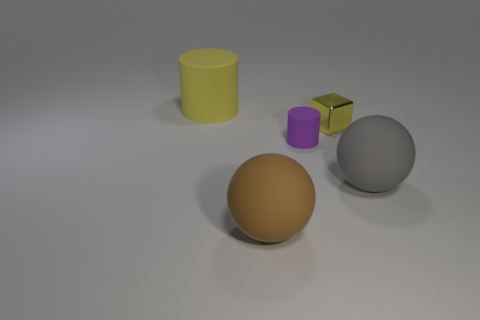Subtract all blocks. How many objects are left? 4 Add 4 large brown shiny cylinders. How many large brown shiny cylinders exist? 4 Add 4 tiny yellow shiny spheres. How many objects exist? 9 Subtract 0 red spheres. How many objects are left? 5 Subtract 1 cylinders. How many cylinders are left? 1 Subtract all blue spheres. Subtract all red cubes. How many spheres are left? 2 Subtract all green cubes. How many cyan cylinders are left? 0 Subtract all big blue cubes. Subtract all matte spheres. How many objects are left? 3 Add 4 yellow objects. How many yellow objects are left? 6 